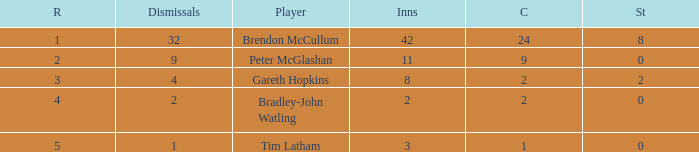How many innings had a total of 2 catches and 0 stumpings? 1.0. Could you help me parse every detail presented in this table? {'header': ['R', 'Dismissals', 'Player', 'Inns', 'C', 'St'], 'rows': [['1', '32', 'Brendon McCullum', '42', '24', '8'], ['2', '9', 'Peter McGlashan', '11', '9', '0'], ['3', '4', 'Gareth Hopkins', '8', '2', '2'], ['4', '2', 'Bradley-John Watling', '2', '2', '0'], ['5', '1', 'Tim Latham', '3', '1', '0']]} 